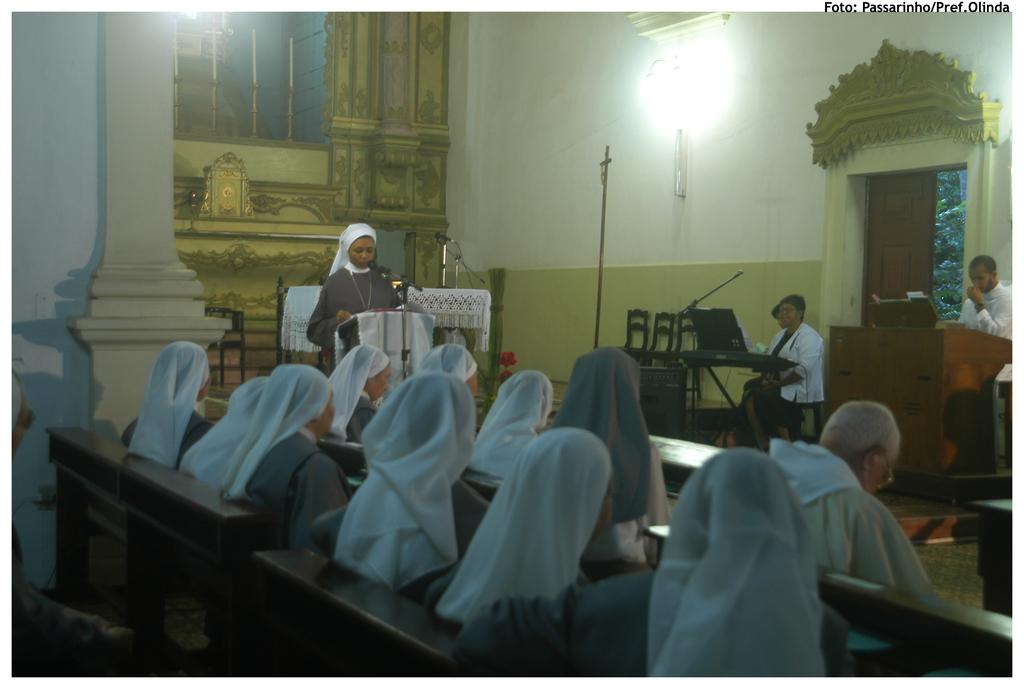What are the people in the image doing? There are people sitting on a bench in the image. What is the woman at the front of the image doing? There is a woman standing at a podium in the image. What can be seen in the background of the image? There are chairs and people at the podium in the background of the image, as well as a wall. How many pigs are present in the image? There are no pigs present in the image. What is the surprise that the writer is about to reveal at the podium? There is no writer or surprise mentioned in the image; it only shows people sitting on a bench and a woman standing at a podium. 